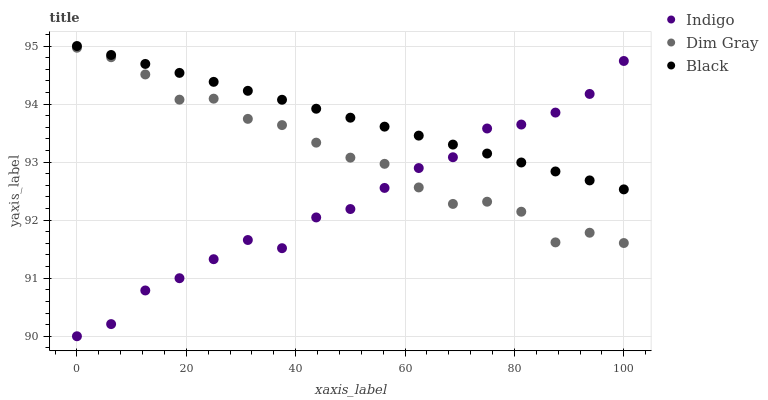Does Indigo have the minimum area under the curve?
Answer yes or no. Yes. Does Black have the maximum area under the curve?
Answer yes or no. Yes. Does Dim Gray have the minimum area under the curve?
Answer yes or no. No. Does Dim Gray have the maximum area under the curve?
Answer yes or no. No. Is Black the smoothest?
Answer yes or no. Yes. Is Dim Gray the roughest?
Answer yes or no. Yes. Is Indigo the smoothest?
Answer yes or no. No. Is Indigo the roughest?
Answer yes or no. No. Does Indigo have the lowest value?
Answer yes or no. Yes. Does Dim Gray have the lowest value?
Answer yes or no. No. Does Black have the highest value?
Answer yes or no. Yes. Does Dim Gray have the highest value?
Answer yes or no. No. Is Dim Gray less than Black?
Answer yes or no. Yes. Is Black greater than Dim Gray?
Answer yes or no. Yes. Does Black intersect Indigo?
Answer yes or no. Yes. Is Black less than Indigo?
Answer yes or no. No. Is Black greater than Indigo?
Answer yes or no. No. Does Dim Gray intersect Black?
Answer yes or no. No. 